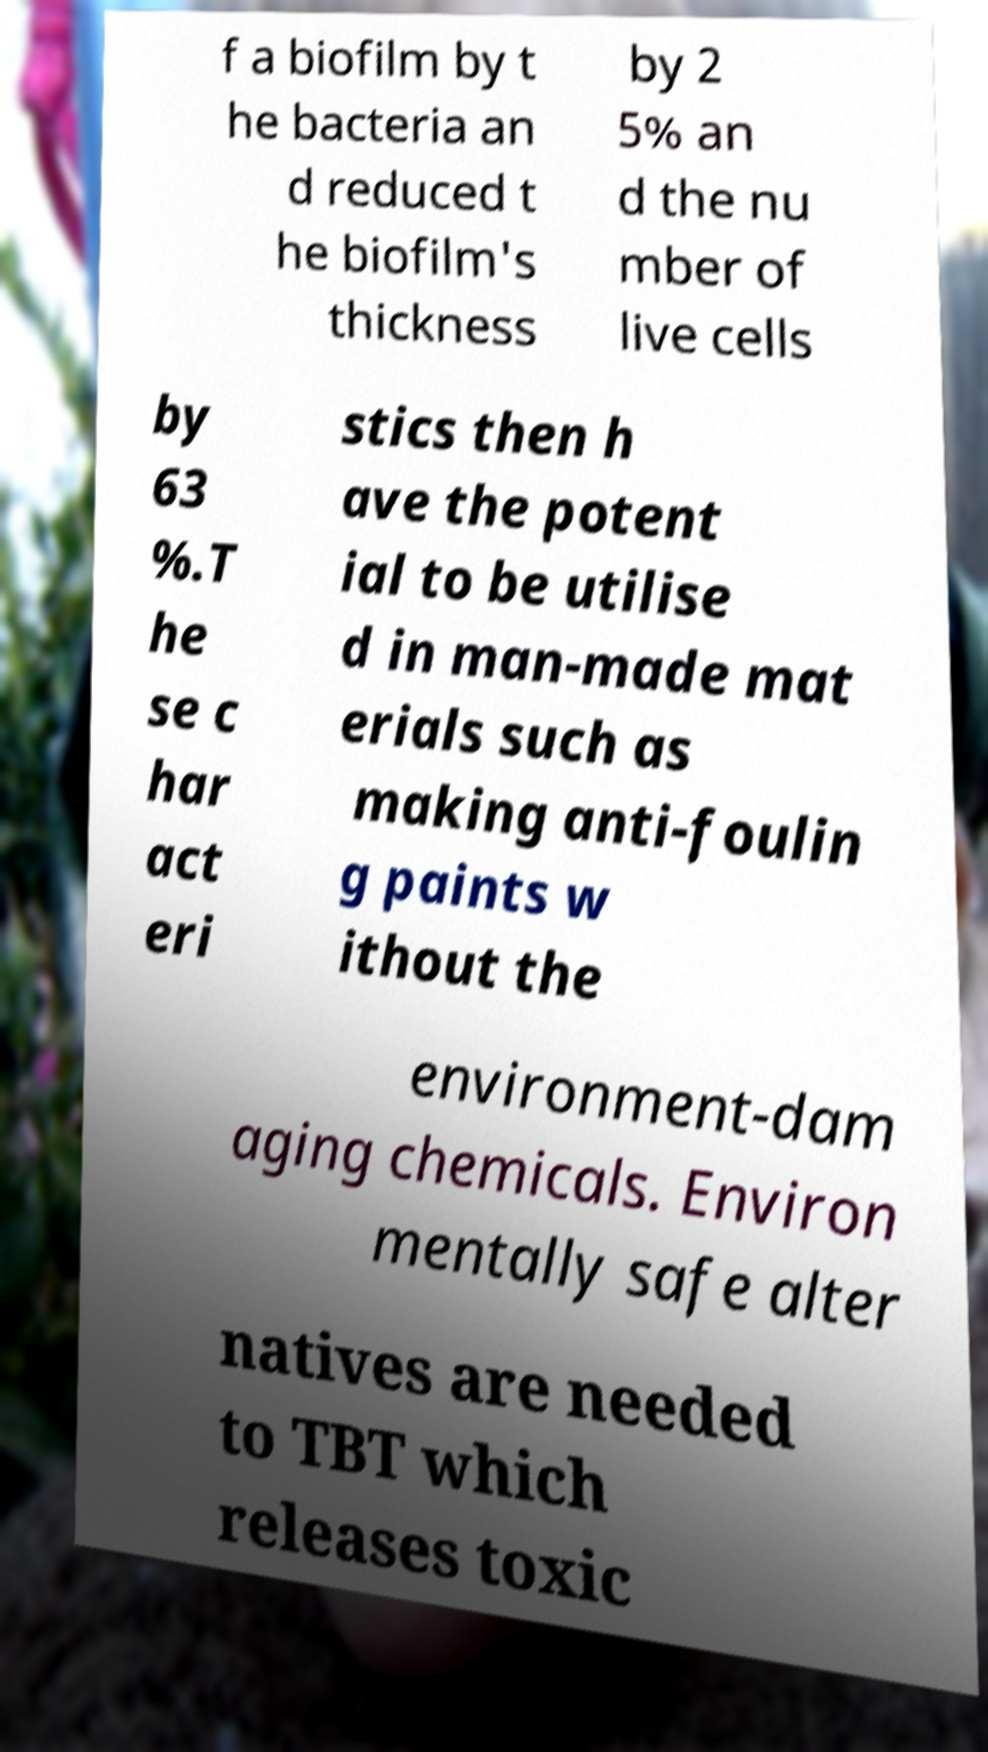For documentation purposes, I need the text within this image transcribed. Could you provide that? f a biofilm by t he bacteria an d reduced t he biofilm's thickness by 2 5% an d the nu mber of live cells by 63 %.T he se c har act eri stics then h ave the potent ial to be utilise d in man-made mat erials such as making anti-foulin g paints w ithout the environment-dam aging chemicals. Environ mentally safe alter natives are needed to TBT which releases toxic 